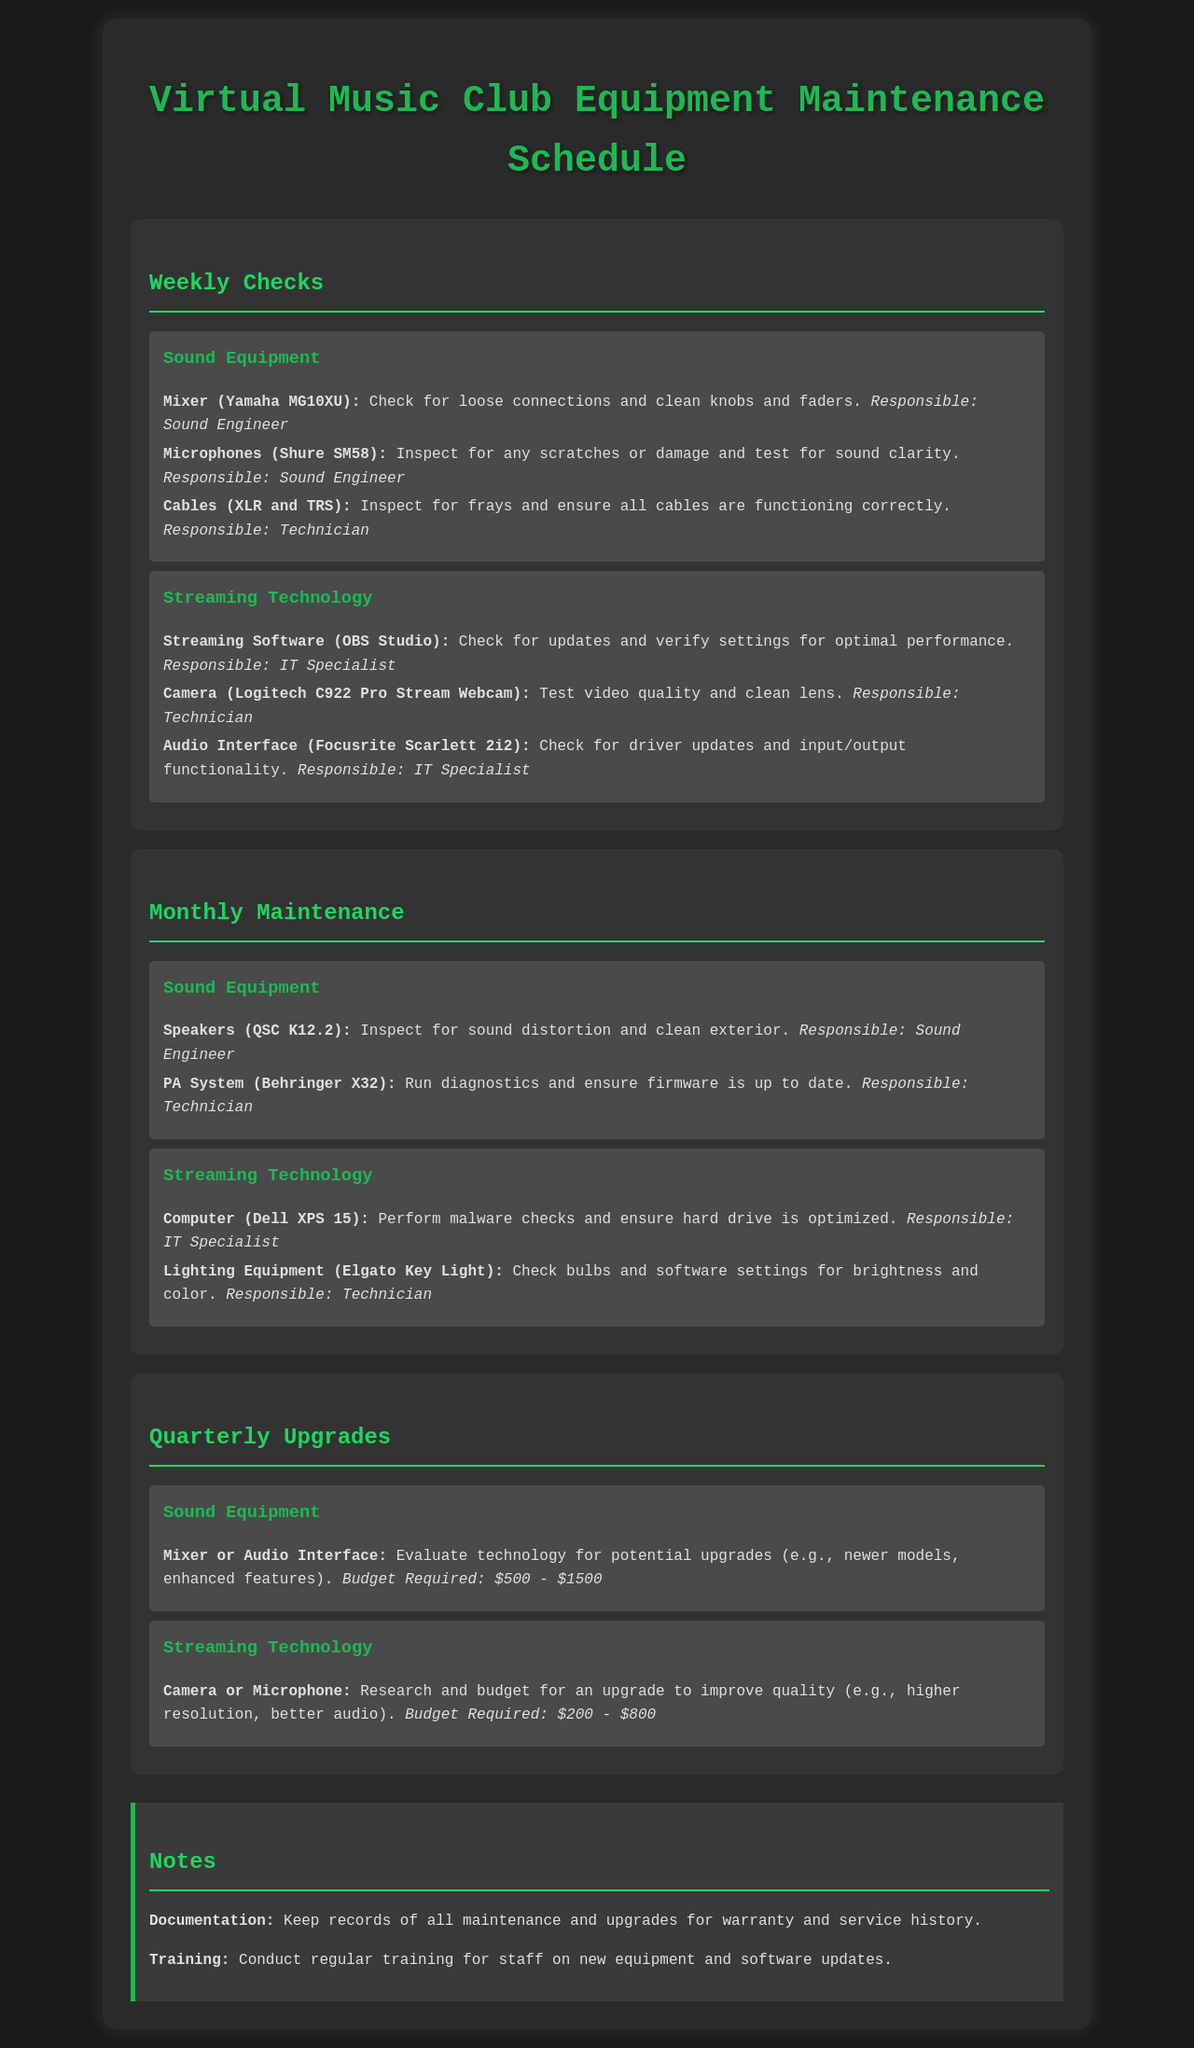what is the name of the mixer? The mixer mentioned in the document is the Yamaha MG10XU.
Answer: Yamaha MG10XU who is responsible for checking the microphones? The document states that the Sound Engineer is responsible for checking the microphones.
Answer: Sound Engineer how often are the lighting equipment checks scheduled? The lighting equipment checks are scheduled monthly.
Answer: Monthly what is the budget required for a camera upgrade? The document specifies that the budget required for a camera upgrade is between 200 and 800 dollars.
Answer: 200 - 800 what type of webcam is used for streaming? The webcam mentioned for streaming is the Logitech C922 Pro Stream Webcam.
Answer: Logitech C922 Pro Stream Webcam what action is suggested for the Dell XPS 15? The document suggests performing malware checks on the Dell XPS 15.
Answer: Perform malware checks how many types of maintenance schedules are mentioned in the document? The document includes three types of maintenance schedules: Weekly Checks, Monthly Maintenance, and Quarterly Upgrades.
Answer: Three what should staff be trained on according to the notes? The document indicates that staff should be trained on new equipment and software updates.
Answer: New equipment and software updates how often should the PA system diagnostics be run? The diagnostics for the PA system are scheduled for monthly maintenance.
Answer: Monthly 